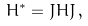<formula> <loc_0><loc_0><loc_500><loc_500>H ^ { * } = J H J \, ,</formula> 